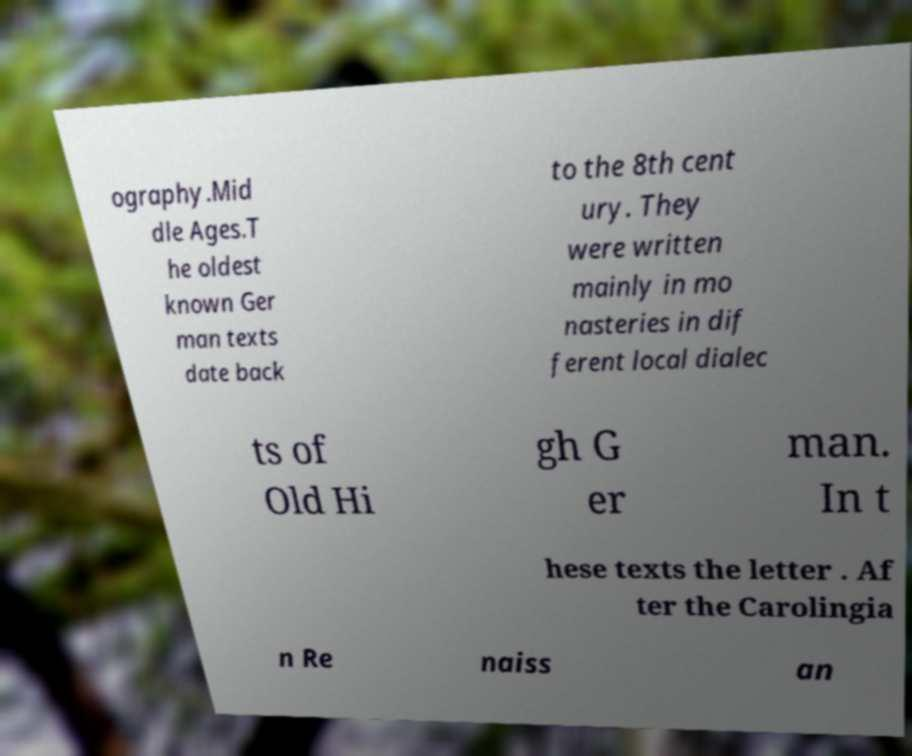There's text embedded in this image that I need extracted. Can you transcribe it verbatim? ography.Mid dle Ages.T he oldest known Ger man texts date back to the 8th cent ury. They were written mainly in mo nasteries in dif ferent local dialec ts of Old Hi gh G er man. In t hese texts the letter . Af ter the Carolingia n Re naiss an 